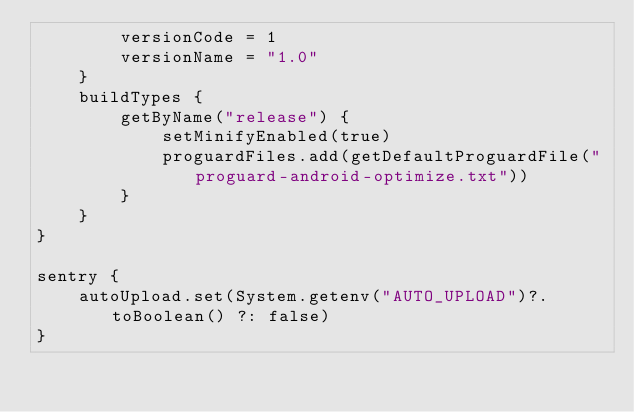Convert code to text. <code><loc_0><loc_0><loc_500><loc_500><_Kotlin_>        versionCode = 1
        versionName = "1.0"
    }
    buildTypes {
        getByName("release") {
            setMinifyEnabled(true)
            proguardFiles.add(getDefaultProguardFile("proguard-android-optimize.txt"))
        }
    }
}

sentry {
    autoUpload.set(System.getenv("AUTO_UPLOAD")?.toBoolean() ?: false)
}
</code> 